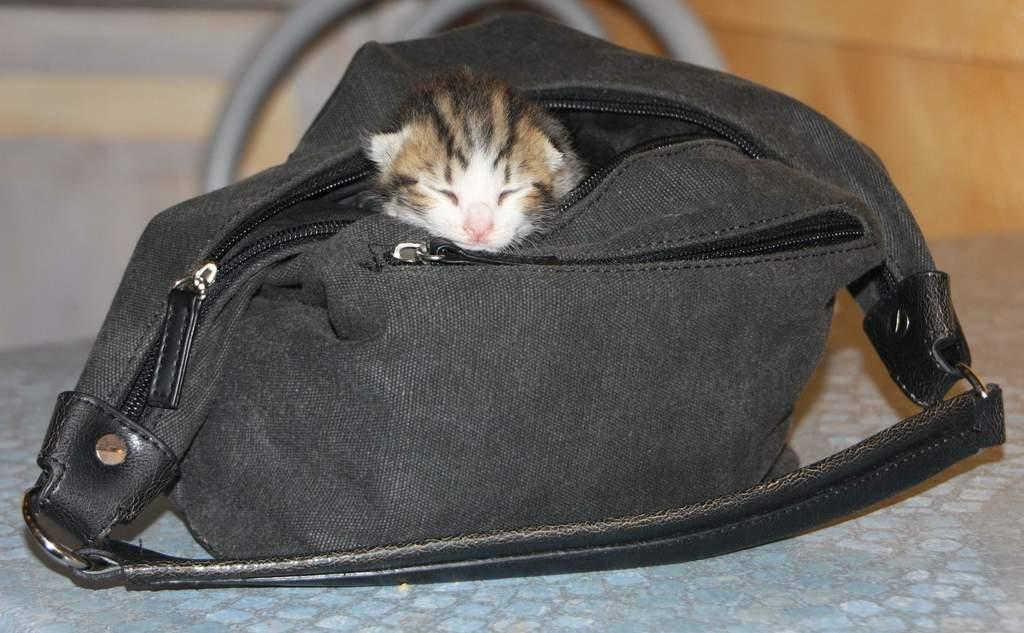What is inside the bag that is visible in the image? There is a cat in the bag. Where is the bag located in the image? The bag is kept on a table. What is behind the table in the image? There is a chair behind the table. What can be seen in the background of the image? A: There is a wall in the background. What type of blade can be seen cutting through the wall in the image? There is no blade or any cutting activity visible in the image; it only features a cat in a bag on a table with a chair behind it and a wall in the background. 